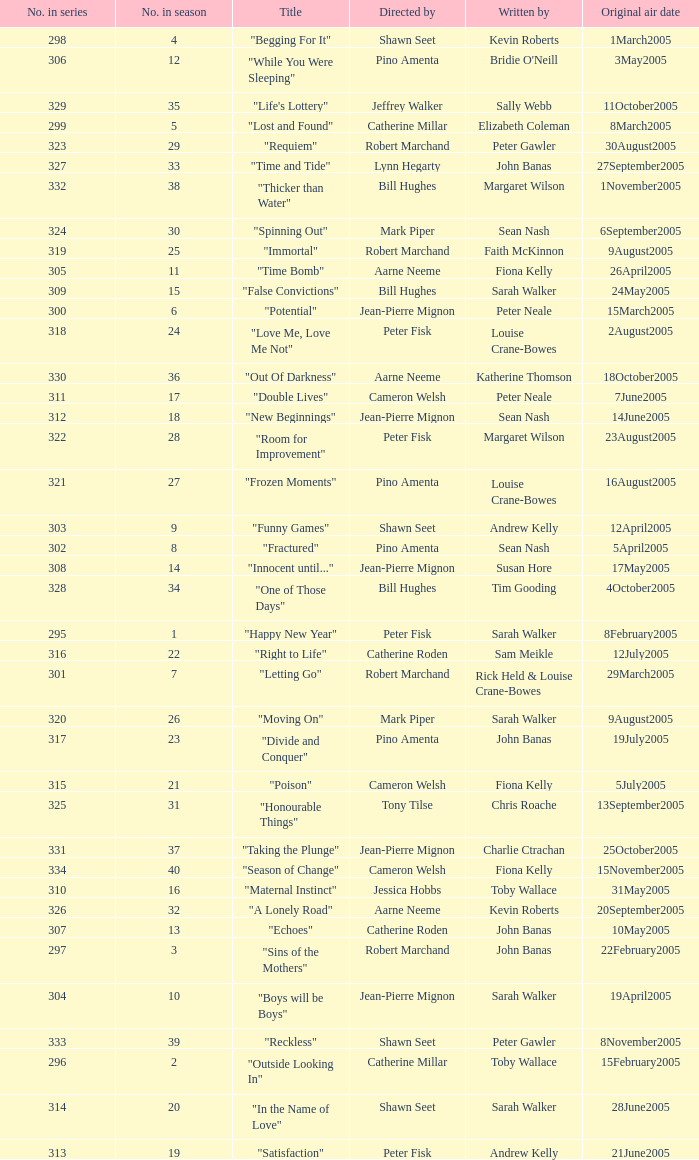Name the total number in the series written by john banas and directed by pino amenta 1.0. 